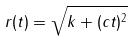Convert formula to latex. <formula><loc_0><loc_0><loc_500><loc_500>r ( t ) = \sqrt { k + ( c t ) ^ { 2 } }</formula> 